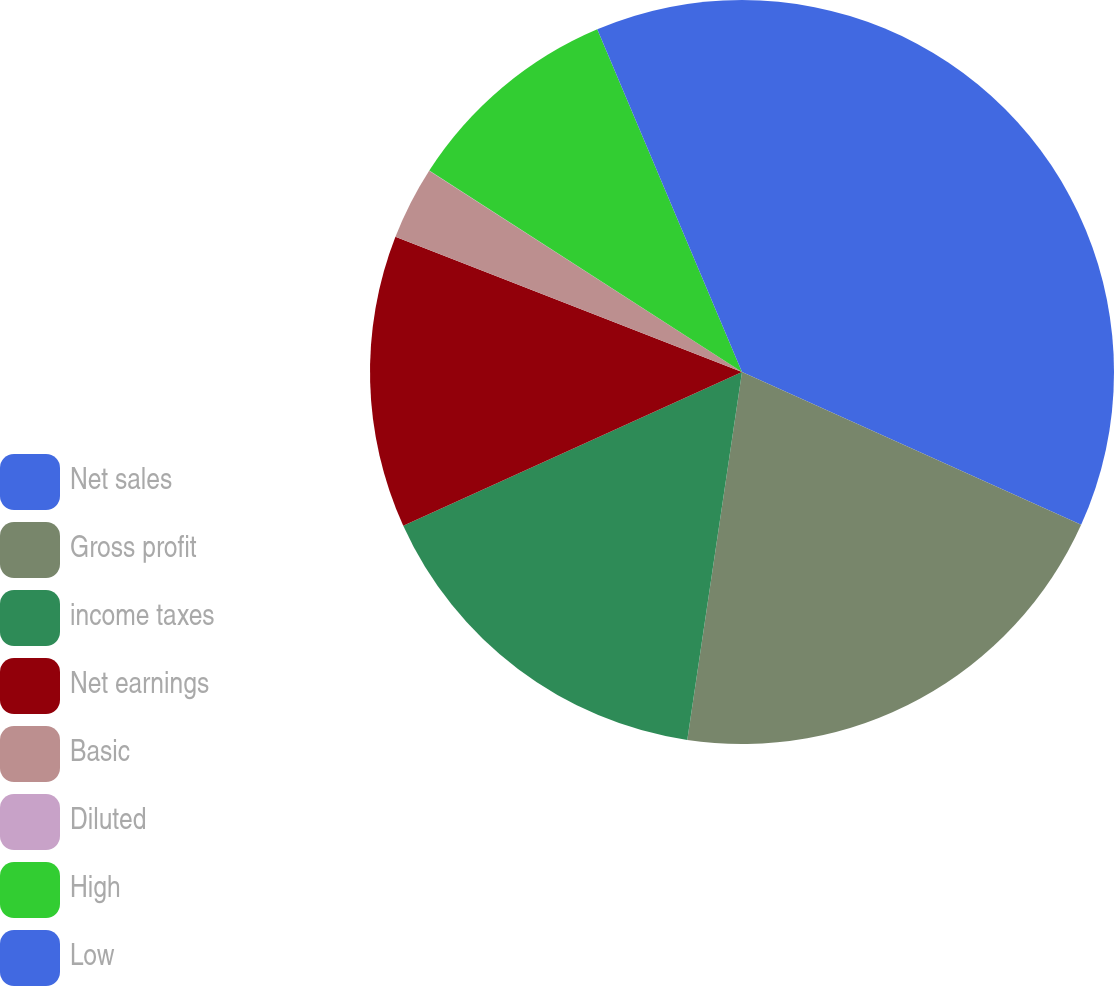<chart> <loc_0><loc_0><loc_500><loc_500><pie_chart><fcel>Net sales<fcel>Gross profit<fcel>income taxes<fcel>Net earnings<fcel>Basic<fcel>Diluted<fcel>High<fcel>Low<nl><fcel>31.74%<fcel>20.61%<fcel>15.87%<fcel>12.7%<fcel>3.18%<fcel>0.01%<fcel>9.53%<fcel>6.36%<nl></chart> 